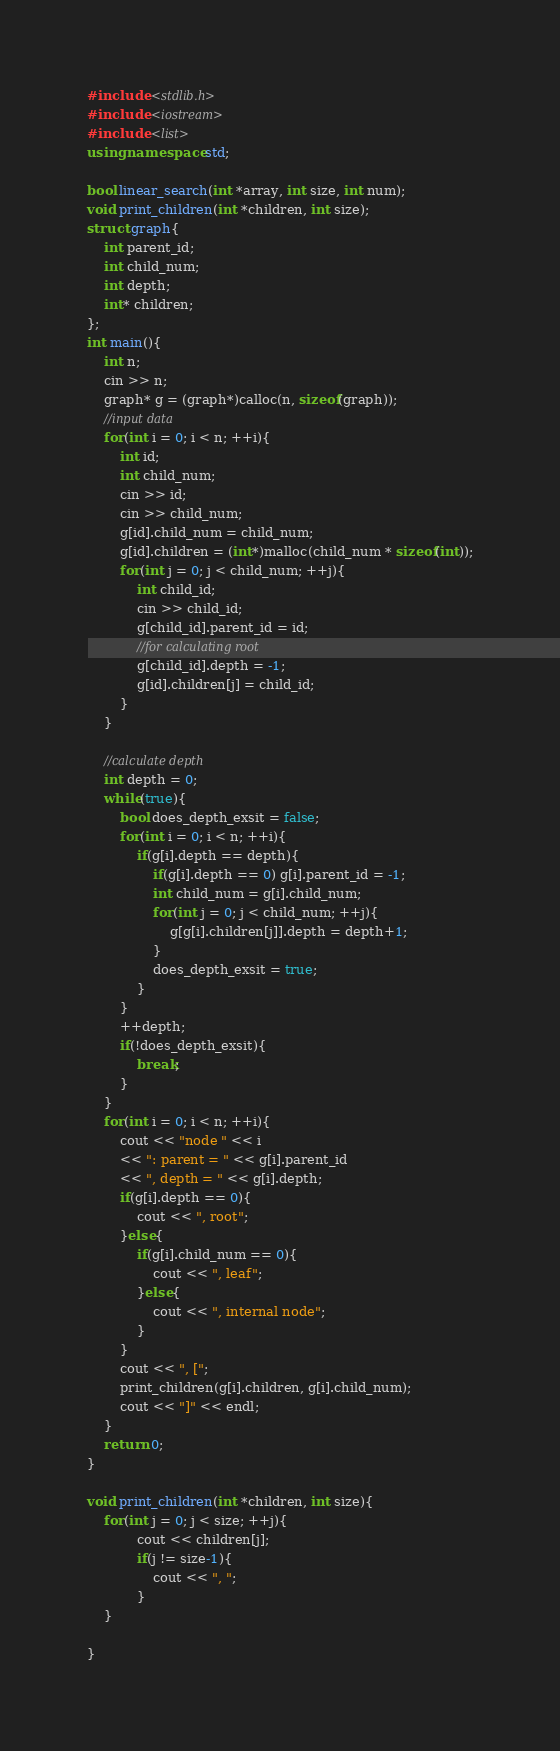Convert code to text. <code><loc_0><loc_0><loc_500><loc_500><_C++_>#include <stdlib.h>
#include <iostream>
#include <list>
using namespace std;

bool linear_search(int *array, int size, int num);
void print_children(int *children, int size);
struct graph{
	int parent_id;
	int child_num;
	int depth;
	int* children;
};
int main(){
	int n;
	cin >> n;
	graph* g = (graph*)calloc(n, sizeof(graph));
	//input data
	for(int i = 0; i < n; ++i){
		int id;
		int child_num;
		cin >> id;
		cin >> child_num;
		g[id].child_num = child_num;
		g[id].children = (int*)malloc(child_num * sizeof(int));
		for(int j = 0; j < child_num; ++j){
			int child_id;
			cin >> child_id;
			g[child_id].parent_id = id;
			//for calculating root
			g[child_id].depth = -1;
			g[id].children[j] = child_id;
		}
	}

	//calculate depth
	int depth = 0;
	while(true){
		bool does_depth_exsit = false;
		for(int i = 0; i < n; ++i){
			if(g[i].depth == depth){
				if(g[i].depth == 0) g[i].parent_id = -1;
				int child_num = g[i].child_num;
				for(int j = 0; j < child_num; ++j){
					g[g[i].children[j]].depth = depth+1;
				}
				does_depth_exsit = true;
			}
		}
		++depth;
		if(!does_depth_exsit){
			break;
		}
	}
	for(int i = 0; i < n; ++i){
		cout << "node " << i
		<< ": parent = " << g[i].parent_id
		<< ", depth = " << g[i].depth;
		if(g[i].depth == 0){
			cout << ", root";
		}else{
			if(g[i].child_num == 0){
				cout << ", leaf";
			}else{
				cout << ", internal node";
			}
		}
		cout << ", [";
		print_children(g[i].children, g[i].child_num);
		cout << "]" << endl;
	}
	return 0;
}

void print_children(int *children, int size){
	for(int j = 0; j < size; ++j){
		 	cout << children[j];
		 	if(j != size-1){
		 		cout << ", ";
		 	}
	}

}</code> 